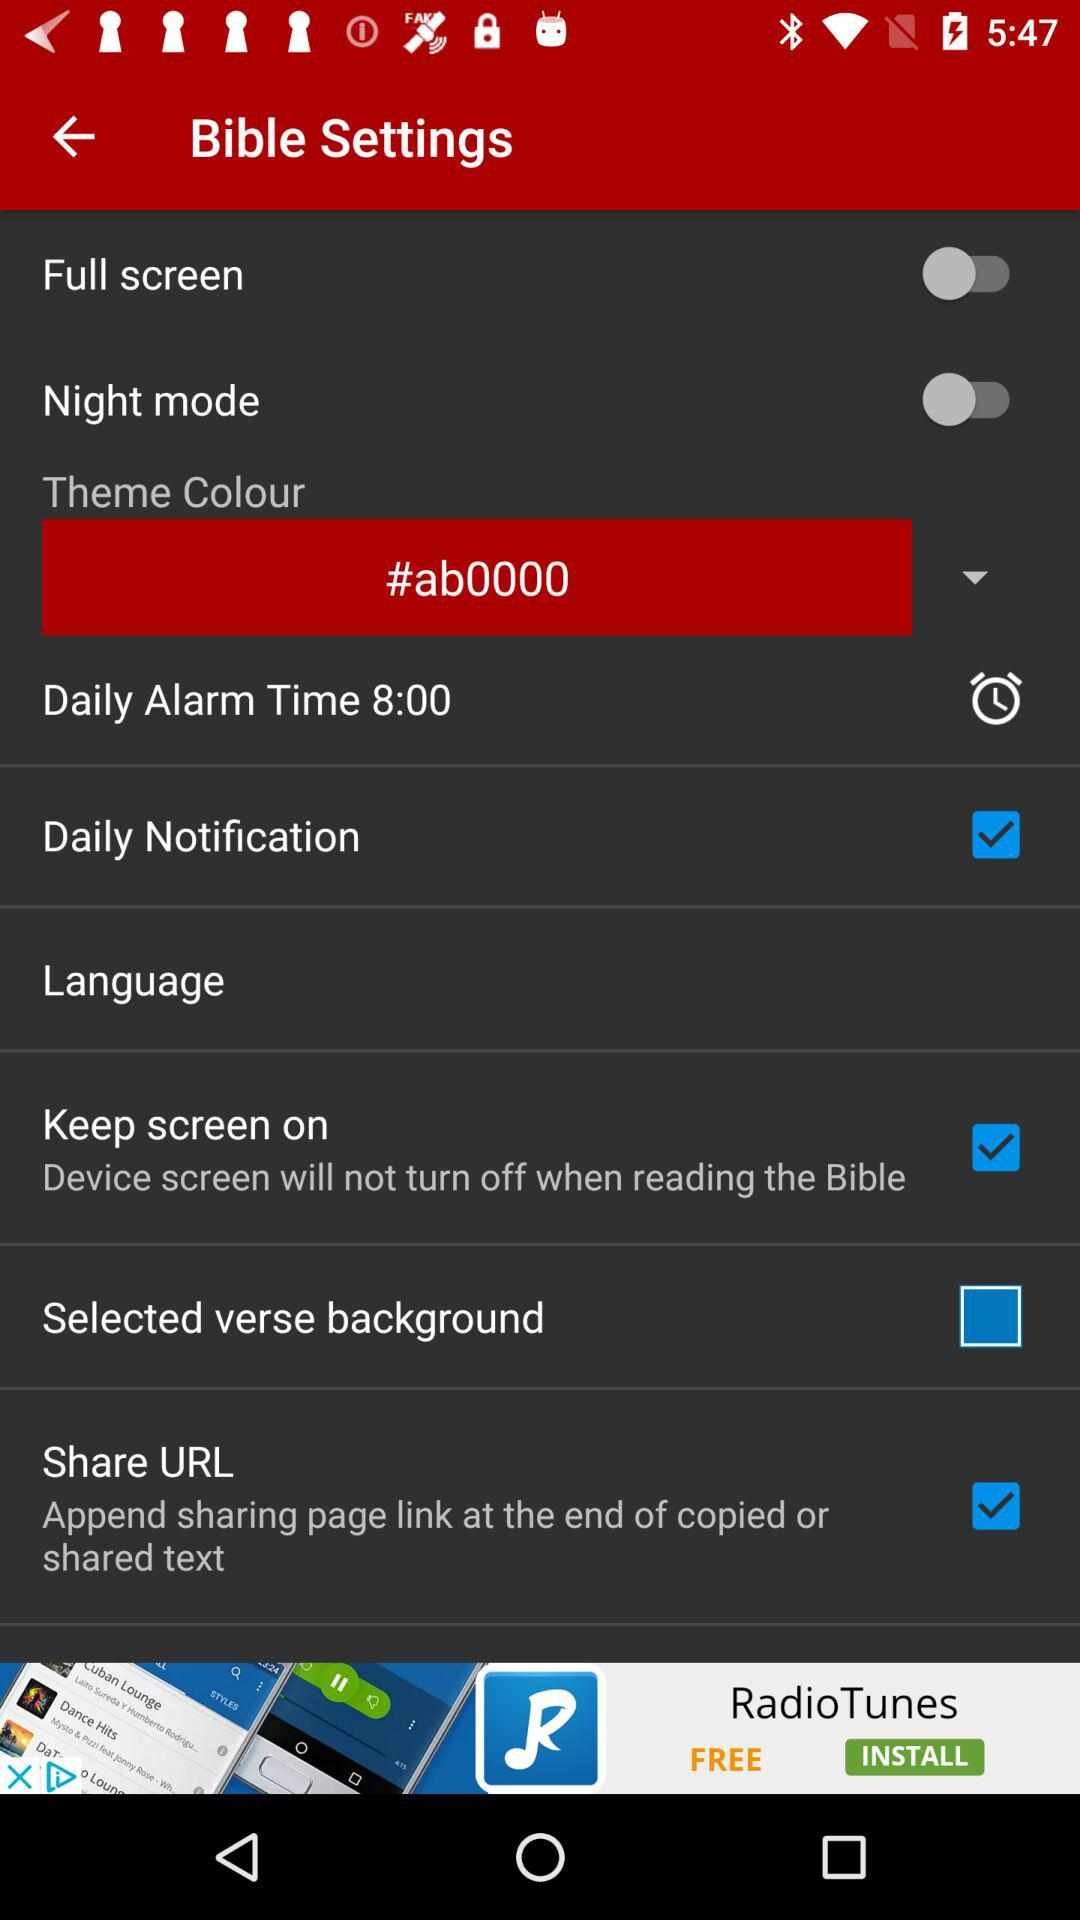Which theme colour is selected? The selected theme colour is "#ab0000". 